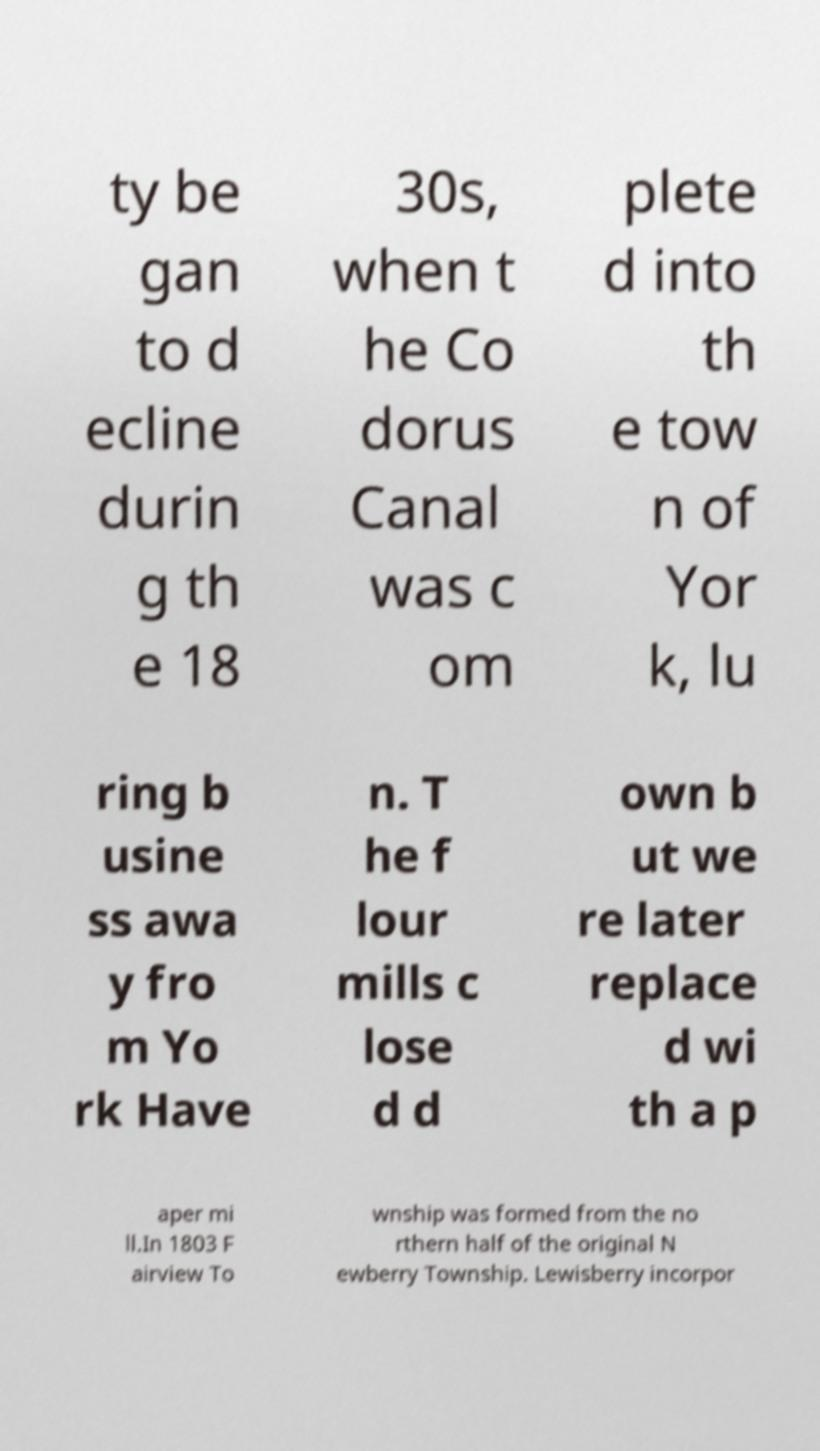For documentation purposes, I need the text within this image transcribed. Could you provide that? ty be gan to d ecline durin g th e 18 30s, when t he Co dorus Canal was c om plete d into th e tow n of Yor k, lu ring b usine ss awa y fro m Yo rk Have n. T he f lour mills c lose d d own b ut we re later replace d wi th a p aper mi ll.In 1803 F airview To wnship was formed from the no rthern half of the original N ewberry Township. Lewisberry incorpor 